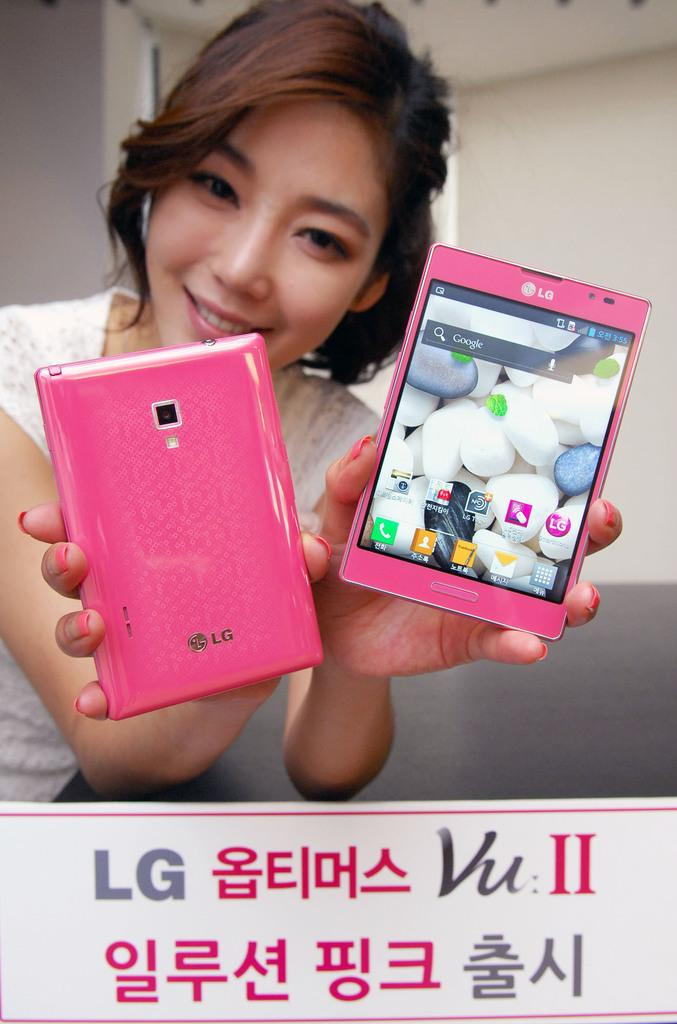Provide a one-sentence caption for the provided image. a girl is posing for a picture with two LG branded pink phones with korean text on the bottom. 